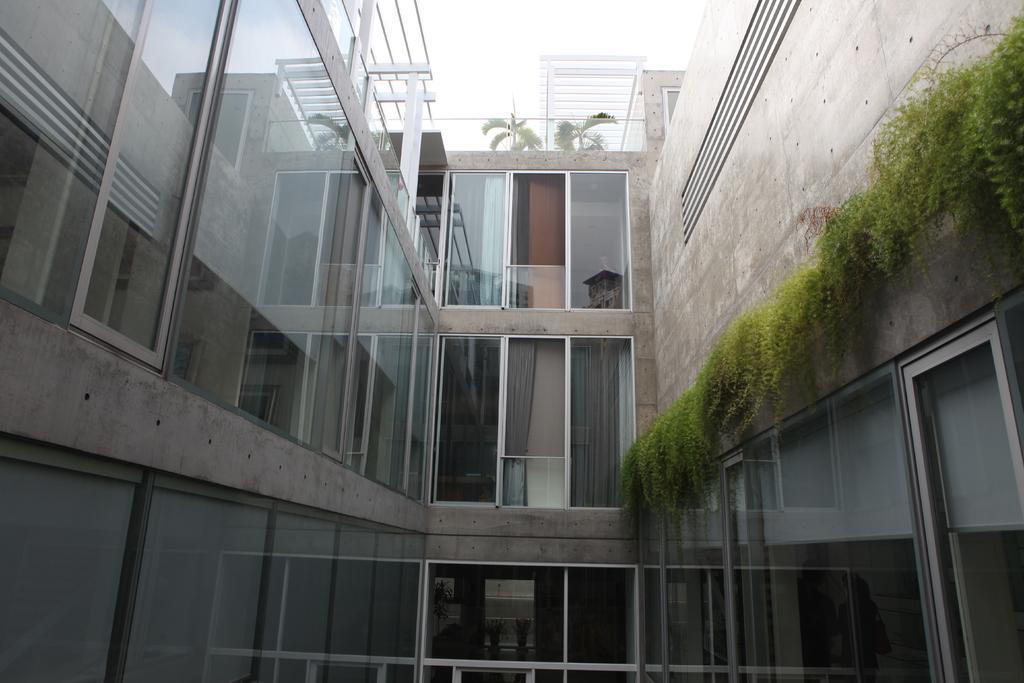Describe this image in one or two sentences. In this image there is a building with walls, windows and doors. There are a few plants. There are a few iron bars. There are two trees. At the top of the image there is the sky. 